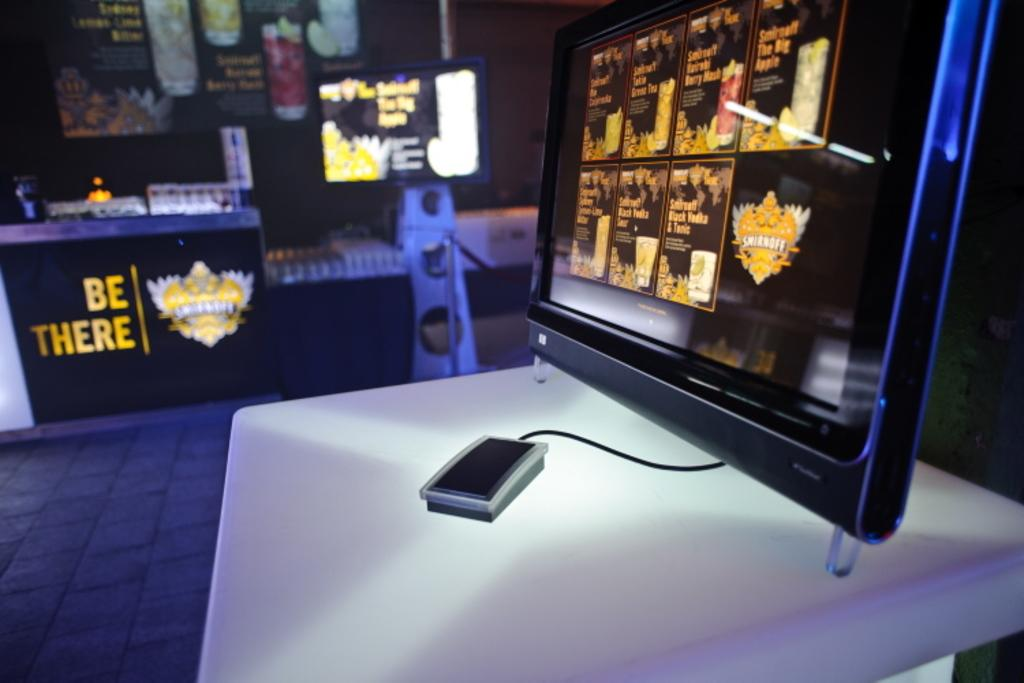<image>
Provide a brief description of the given image. monitors and tables with the words Be There on them 